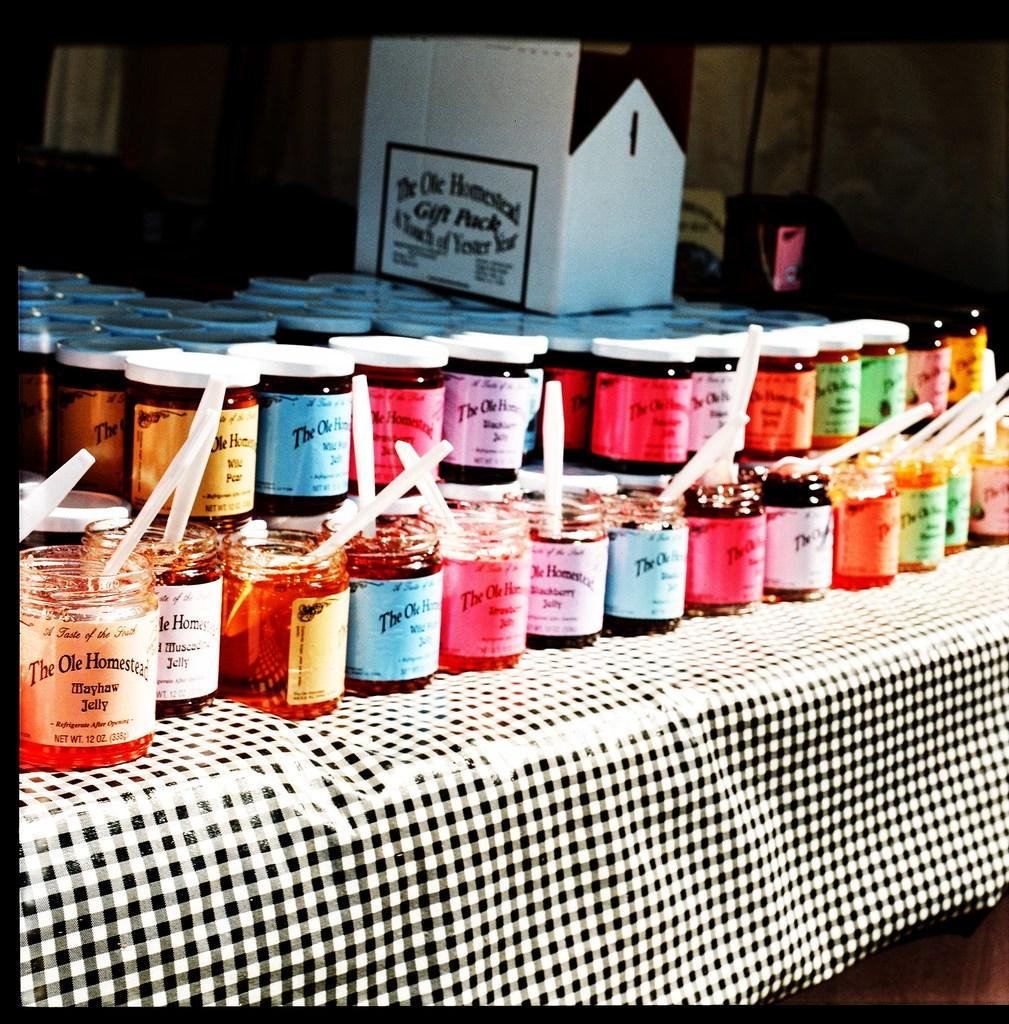<image>
Offer a succinct explanation of the picture presented. Jars on a table with one of them saying The ole Homestead. 